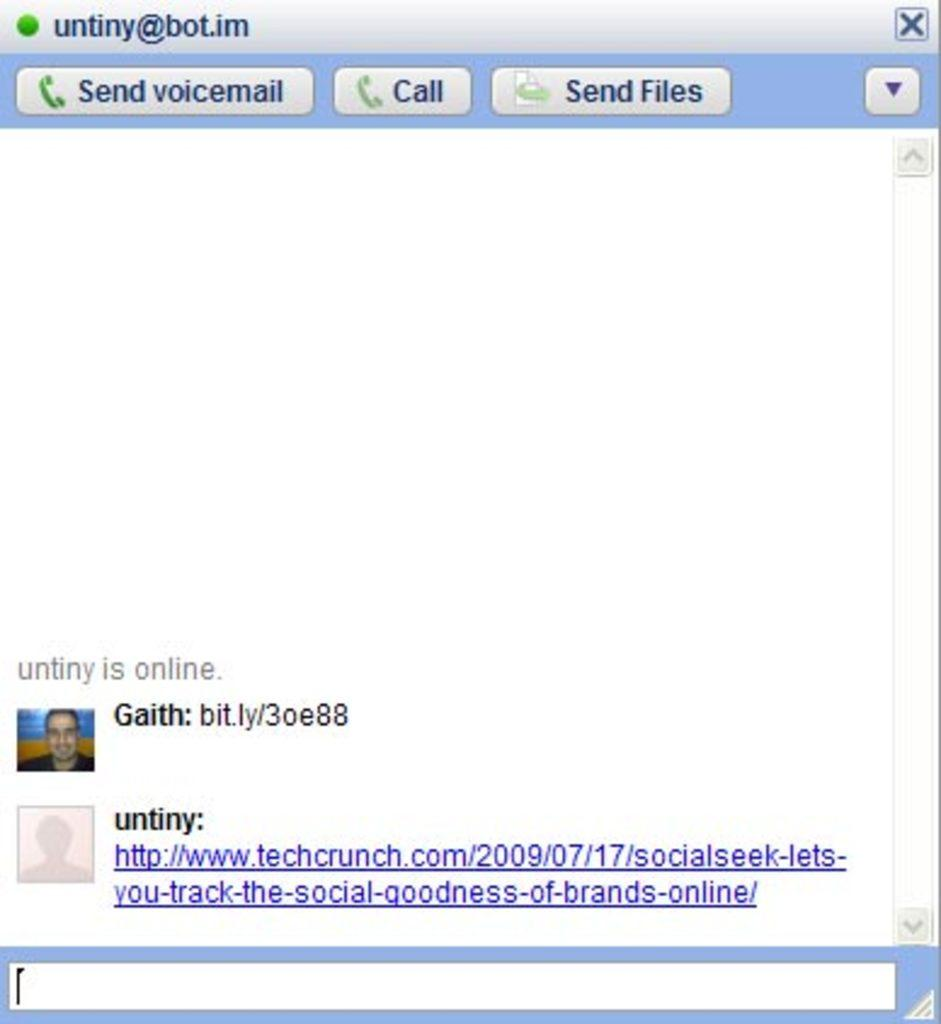What type of image is shown in the screenshot? The image is a screenshot of a chat. Can you identify any participants in the chat? Yes, there is a person in the chat. What can be seen in the chat besides the person? There is text visible in the chat. How many cows are visible in the chat? There are no cows visible in the chat; it contains a person and text. What type of lace is being used to decorate the chat? There is no lace present in the chat; it is a screenshot of a text-based conversation. 